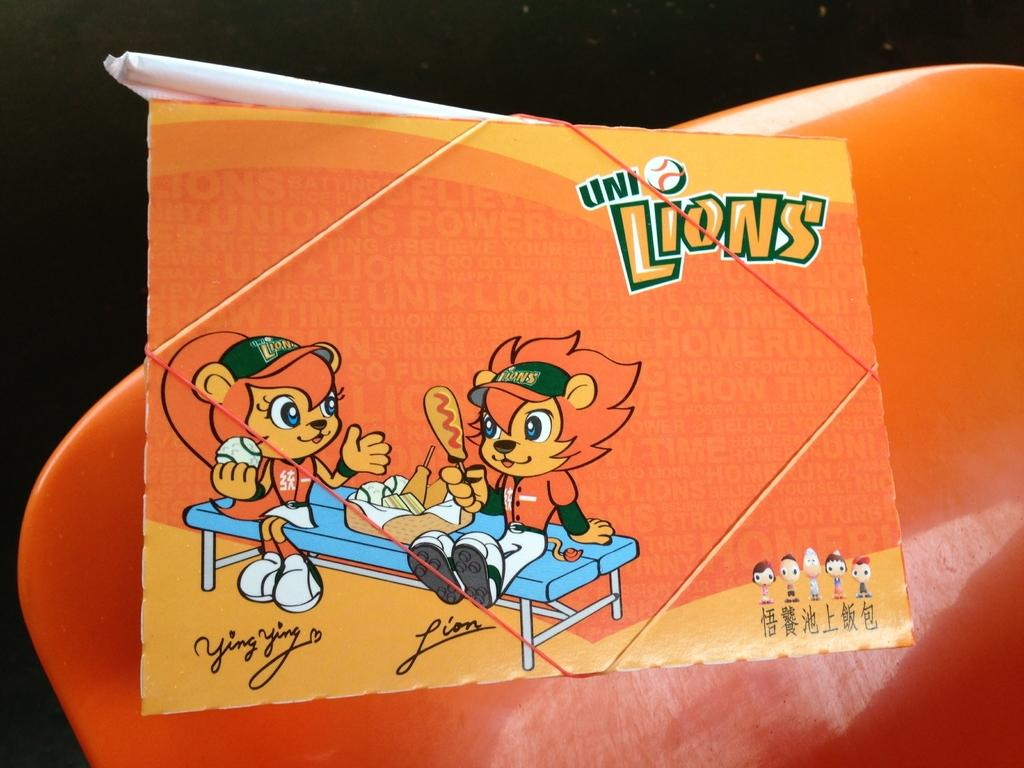What is the main subject of the image? The main subject of the image is an orange cartoon paper. What other orange object can be seen in the image? There is an orange chair back in the image. What color is the background of the image? The background of the image is black. What type of desk is visible in the image? There is no desk present in the image. What day of the week is depicted in the image? The image does not depict a specific day of the week. 